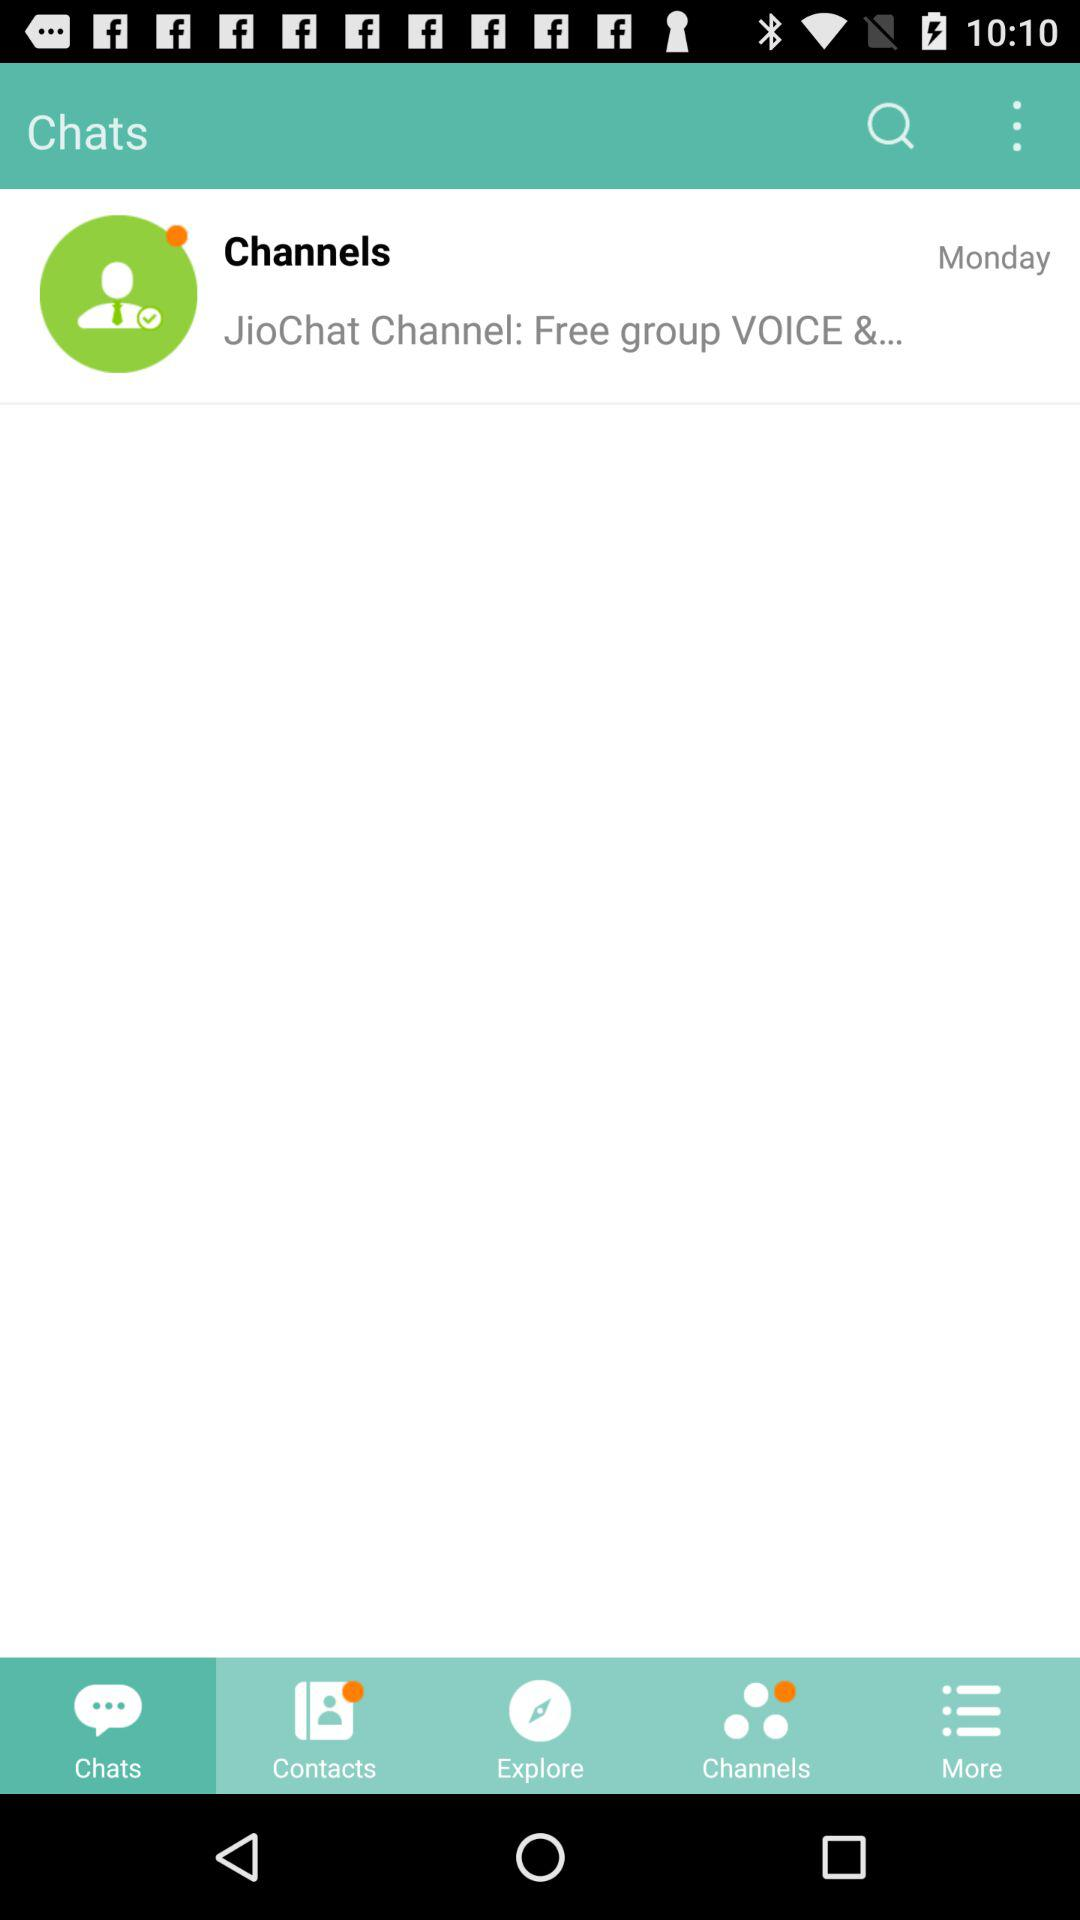On what day was the message received? The message was received on Monday. 